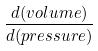Convert formula to latex. <formula><loc_0><loc_0><loc_500><loc_500>\frac { d ( v o l u m e ) } { d ( p r e s s u r e ) }</formula> 